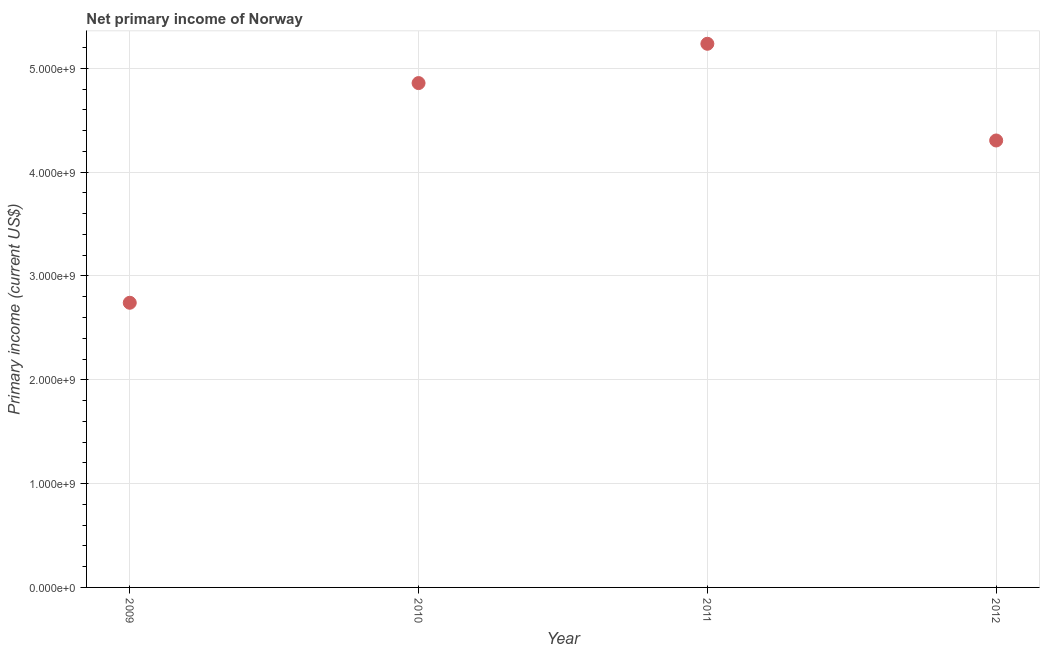What is the amount of primary income in 2009?
Offer a terse response. 2.74e+09. Across all years, what is the maximum amount of primary income?
Give a very brief answer. 5.24e+09. Across all years, what is the minimum amount of primary income?
Your response must be concise. 2.74e+09. In which year was the amount of primary income maximum?
Provide a short and direct response. 2011. In which year was the amount of primary income minimum?
Ensure brevity in your answer.  2009. What is the sum of the amount of primary income?
Your answer should be very brief. 1.71e+1. What is the difference between the amount of primary income in 2009 and 2010?
Offer a very short reply. -2.12e+09. What is the average amount of primary income per year?
Offer a very short reply. 4.29e+09. What is the median amount of primary income?
Make the answer very short. 4.58e+09. In how many years, is the amount of primary income greater than 3400000000 US$?
Give a very brief answer. 3. Do a majority of the years between 2009 and 2011 (inclusive) have amount of primary income greater than 2800000000 US$?
Keep it short and to the point. Yes. What is the ratio of the amount of primary income in 2010 to that in 2011?
Offer a very short reply. 0.93. Is the amount of primary income in 2009 less than that in 2012?
Your answer should be very brief. Yes. Is the difference between the amount of primary income in 2009 and 2010 greater than the difference between any two years?
Your answer should be very brief. No. What is the difference between the highest and the second highest amount of primary income?
Ensure brevity in your answer.  3.79e+08. What is the difference between the highest and the lowest amount of primary income?
Give a very brief answer. 2.49e+09. In how many years, is the amount of primary income greater than the average amount of primary income taken over all years?
Provide a succinct answer. 3. How many dotlines are there?
Keep it short and to the point. 1. What is the difference between two consecutive major ticks on the Y-axis?
Ensure brevity in your answer.  1.00e+09. Are the values on the major ticks of Y-axis written in scientific E-notation?
Keep it short and to the point. Yes. Does the graph contain grids?
Your answer should be very brief. Yes. What is the title of the graph?
Offer a terse response. Net primary income of Norway. What is the label or title of the X-axis?
Offer a terse response. Year. What is the label or title of the Y-axis?
Ensure brevity in your answer.  Primary income (current US$). What is the Primary income (current US$) in 2009?
Offer a terse response. 2.74e+09. What is the Primary income (current US$) in 2010?
Provide a succinct answer. 4.86e+09. What is the Primary income (current US$) in 2011?
Your answer should be compact. 5.24e+09. What is the Primary income (current US$) in 2012?
Offer a terse response. 4.31e+09. What is the difference between the Primary income (current US$) in 2009 and 2010?
Ensure brevity in your answer.  -2.12e+09. What is the difference between the Primary income (current US$) in 2009 and 2011?
Provide a succinct answer. -2.49e+09. What is the difference between the Primary income (current US$) in 2009 and 2012?
Give a very brief answer. -1.56e+09. What is the difference between the Primary income (current US$) in 2010 and 2011?
Your answer should be very brief. -3.79e+08. What is the difference between the Primary income (current US$) in 2010 and 2012?
Offer a terse response. 5.53e+08. What is the difference between the Primary income (current US$) in 2011 and 2012?
Make the answer very short. 9.32e+08. What is the ratio of the Primary income (current US$) in 2009 to that in 2010?
Keep it short and to the point. 0.56. What is the ratio of the Primary income (current US$) in 2009 to that in 2011?
Provide a short and direct response. 0.52. What is the ratio of the Primary income (current US$) in 2009 to that in 2012?
Give a very brief answer. 0.64. What is the ratio of the Primary income (current US$) in 2010 to that in 2011?
Ensure brevity in your answer.  0.93. What is the ratio of the Primary income (current US$) in 2010 to that in 2012?
Provide a short and direct response. 1.13. What is the ratio of the Primary income (current US$) in 2011 to that in 2012?
Your response must be concise. 1.22. 